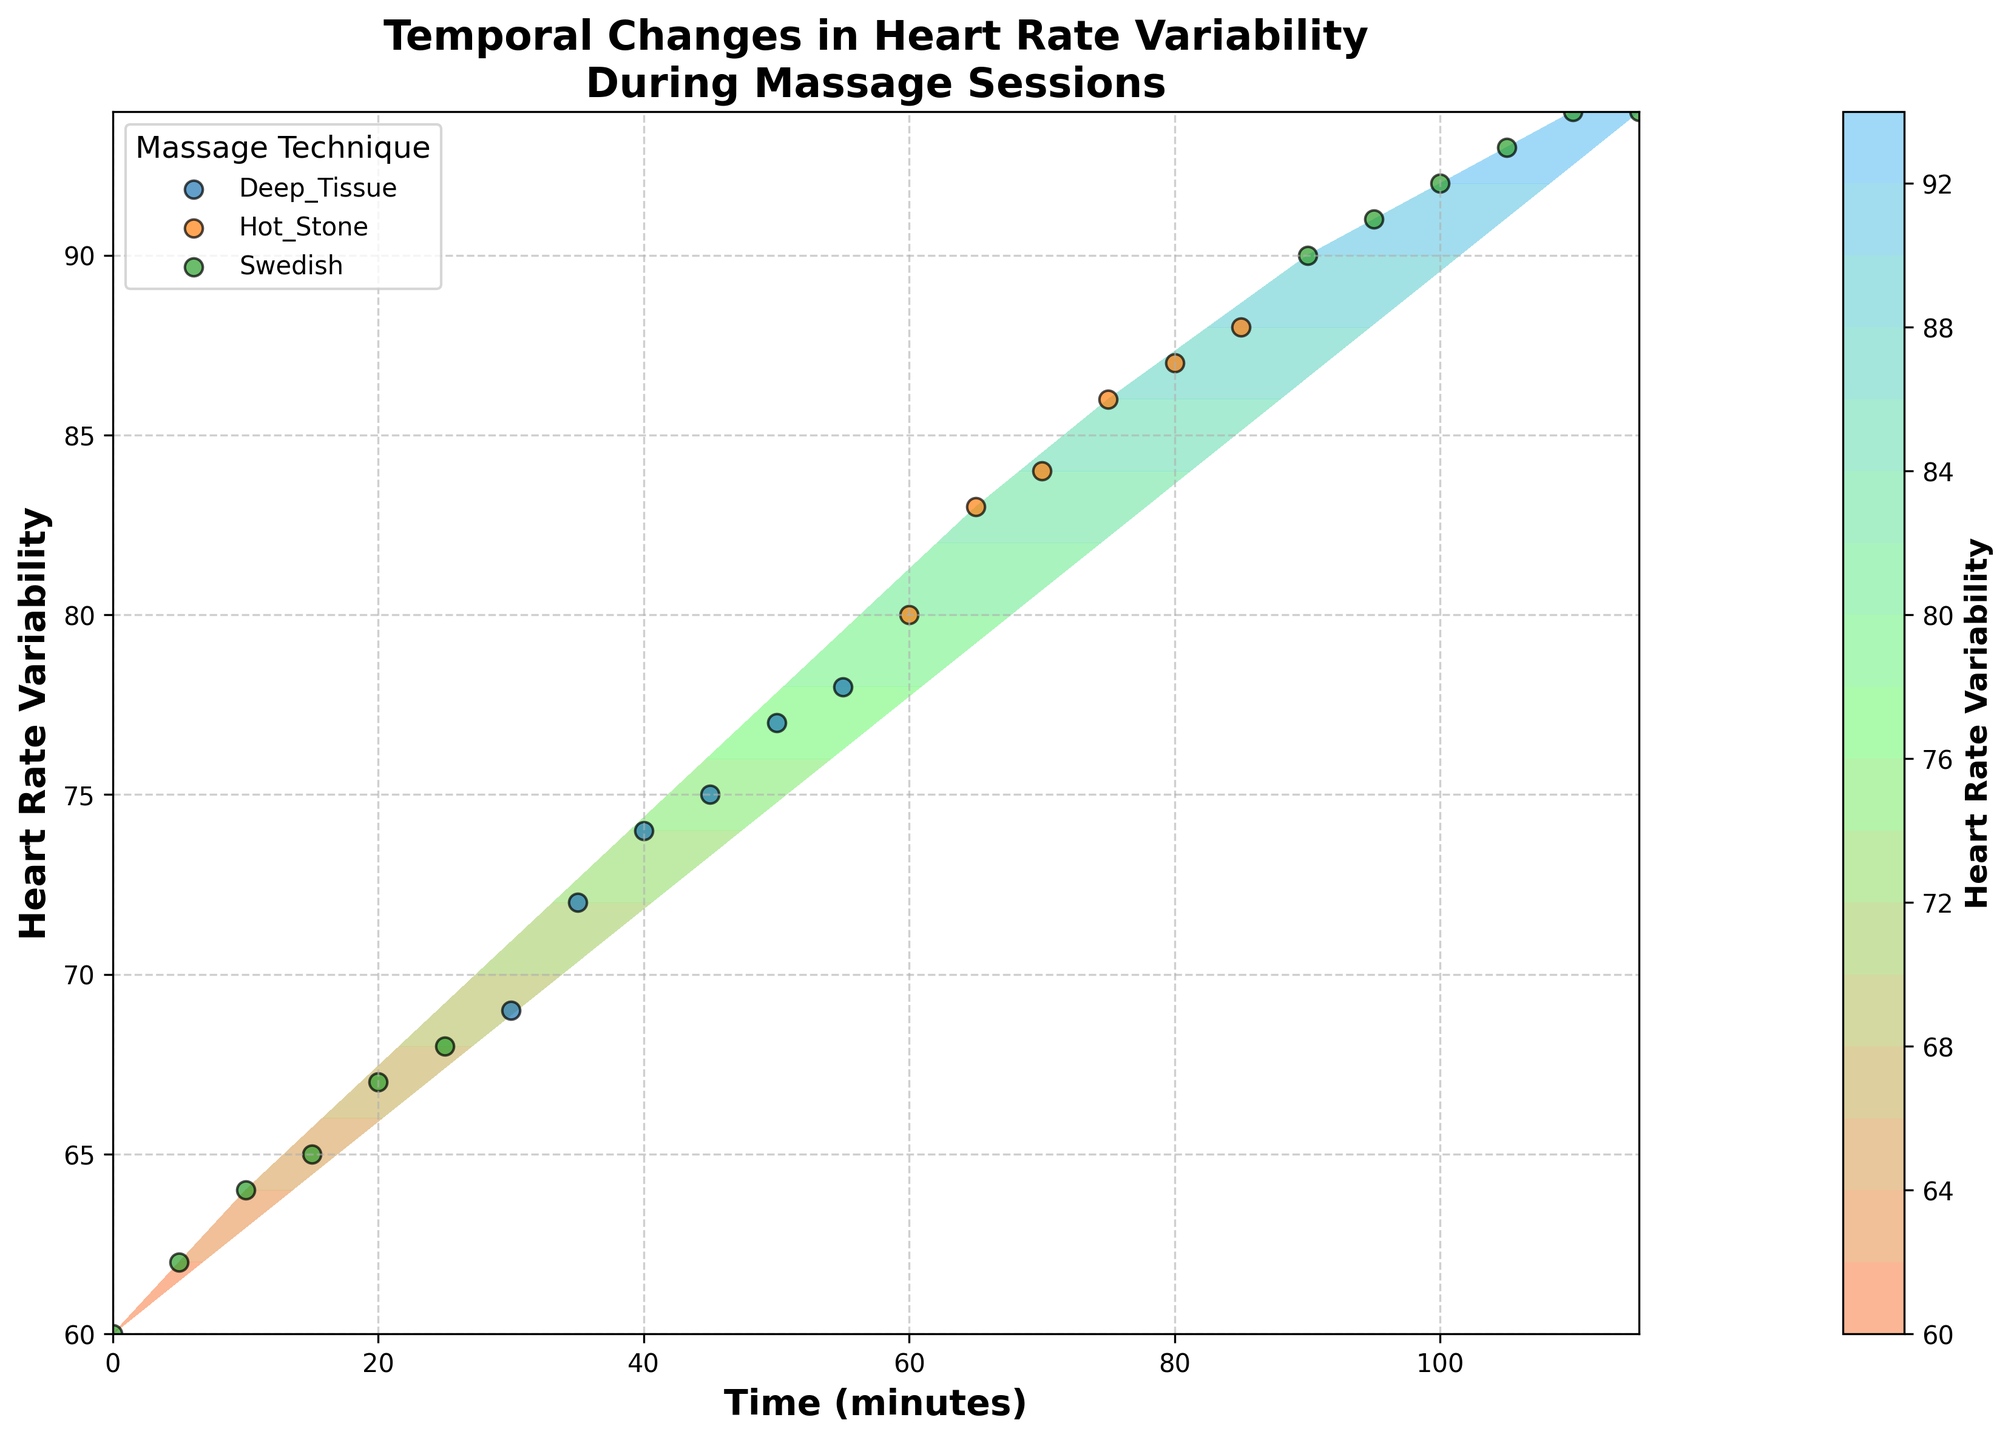What's the title of the figure? The title is displayed at the top of the figure and summarizes the content. It reads, "Temporal Changes in Heart Rate Variability During Massage Sessions."
Answer: Temporal Changes in Heart Rate Variability During Massage Sessions What are the labels of the axes in the figure? The x-axis label at the bottom specifies "Time (minutes)" and the y-axis label on the side specifies "Heart Rate Variability."
Answer: Time (minutes), Heart Rate Variability How does the Heart Rate Variability change over time with the Swedish massage technique? By examining the data points associated with the Swedish massage technique (visible via labeled scatter points), the Heart Rate Variability increases steadily, starting from 60 and peaking at 94 by the end.
Answer: Increases At what time does the Heart Rate Variability first reach 80? By reading the contour plot and identifying the data points, the Heart Rate Variability reaches 80 at the time mark of 60 minutes.
Answer: 60 minutes What massage technique shows the highest Heart Rate Variability and what is that value? By looking at the labeled scatter points and ensuring the corresponding values on the colorbar, the highest Heart Rate Variability value is 94, seen with the Swedish massage technique.
Answer: Swedish, 94 How do the Heart Rate Variability values compare between the Deep Tissue and Hot Stone massage techniques? Observing the data points, Deep Tissue shows a range of 69 to 78, while Hot Stone ranges from 80 to 88. Thus, Hot Stone shows higher variability values compared to Deep Tissue on the contour plot.
Answer: Hot Stone has higher values During which time periods were different massage techniques used? Reading the scatter points and labels: Swedish is from 0-30 and 90-115 minutes, Deep Tissue is from 30-60 minutes, and Hot Stone is from 60-90 minutes.
Answer: Swedish: 0-30, 90-115 minutes, Deep Tissue: 30-60 minutes, Hot Stone: 60-90 minutes What is the average Heart Rate Variability for the Deep Tissue massage technique? The data points for Deep Tissue are 69, 72, 74, 75, 77, and 78. To find the average: (69 + 72 + 74 + 75 + 77 + 78) / 6 = 74.1667.
Answer: 74.167 How does the Heart Rate Variability during the Hot Stone massage compare to the Swedish massage at similar time periods? Hot Stone is from 60-90 minutes with values ranging from 80-88. For comparison, Swedish starts with lower values at the 0-30 minute range but peaks at 94 toward the end (90-115 minutes). Thus, at earlier stages, Hot Stone has a higher HRV than Swedish, but the highest HRV value is seen in Swedish at the end.
Answer: Hot Stone initially higher, Swedish highest overall What trend can be observed in Heart Rate Variability after each technique change? After switching from Swedish to Deep Tissue, there is a notable increase, and this trend continues upon switching to Hot Stone. Finally, switching back to Swedish toward the end shows a peak HRV.
Answer: Increase after each change 